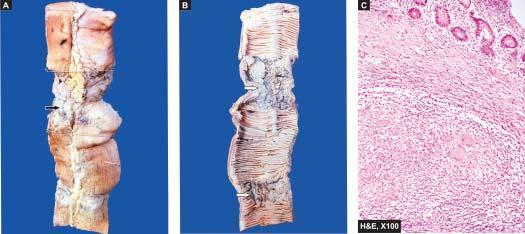does the lumen show characteristic transverse ulcers and two strictures?
Answer the question using a single word or phrase. Yes 